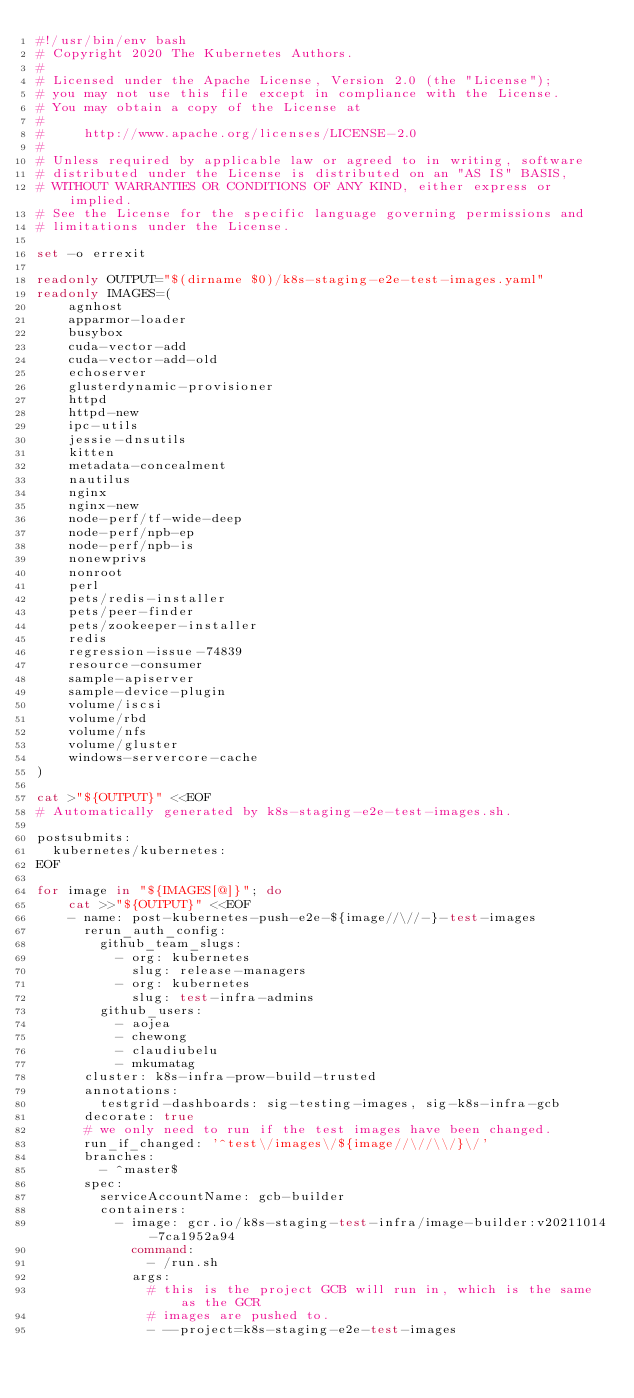<code> <loc_0><loc_0><loc_500><loc_500><_Bash_>#!/usr/bin/env bash
# Copyright 2020 The Kubernetes Authors.
#
# Licensed under the Apache License, Version 2.0 (the "License");
# you may not use this file except in compliance with the License.
# You may obtain a copy of the License at
#
#     http://www.apache.org/licenses/LICENSE-2.0
#
# Unless required by applicable law or agreed to in writing, software
# distributed under the License is distributed on an "AS IS" BASIS,
# WITHOUT WARRANTIES OR CONDITIONS OF ANY KIND, either express or implied.
# See the License for the specific language governing permissions and
# limitations under the License.

set -o errexit

readonly OUTPUT="$(dirname $0)/k8s-staging-e2e-test-images.yaml"
readonly IMAGES=(
    agnhost
    apparmor-loader
    busybox
    cuda-vector-add
    cuda-vector-add-old
    echoserver
    glusterdynamic-provisioner
    httpd
    httpd-new
    ipc-utils
    jessie-dnsutils
    kitten
    metadata-concealment
    nautilus
    nginx
    nginx-new
    node-perf/tf-wide-deep
    node-perf/npb-ep
    node-perf/npb-is
    nonewprivs
    nonroot
    perl
    pets/redis-installer
    pets/peer-finder
    pets/zookeeper-installer
    redis
    regression-issue-74839
    resource-consumer
    sample-apiserver
    sample-device-plugin
    volume/iscsi
    volume/rbd
    volume/nfs
    volume/gluster
    windows-servercore-cache
)

cat >"${OUTPUT}" <<EOF
# Automatically generated by k8s-staging-e2e-test-images.sh.

postsubmits:
  kubernetes/kubernetes:
EOF

for image in "${IMAGES[@]}"; do
    cat >>"${OUTPUT}" <<EOF
    - name: post-kubernetes-push-e2e-${image//\//-}-test-images
      rerun_auth_config:
        github_team_slugs:
          - org: kubernetes
            slug: release-managers
          - org: kubernetes
            slug: test-infra-admins
        github_users:
          - aojea
          - chewong
          - claudiubelu
          - mkumatag
      cluster: k8s-infra-prow-build-trusted
      annotations:
        testgrid-dashboards: sig-testing-images, sig-k8s-infra-gcb
      decorate: true
      # we only need to run if the test images have been changed.
      run_if_changed: '^test\/images\/${image//\//\\/}\/'
      branches:
        - ^master$
      spec:
        serviceAccountName: gcb-builder
        containers:
          - image: gcr.io/k8s-staging-test-infra/image-builder:v20211014-7ca1952a94
            command:
              - /run.sh
            args:
              # this is the project GCB will run in, which is the same as the GCR
              # images are pushed to.
              - --project=k8s-staging-e2e-test-images</code> 